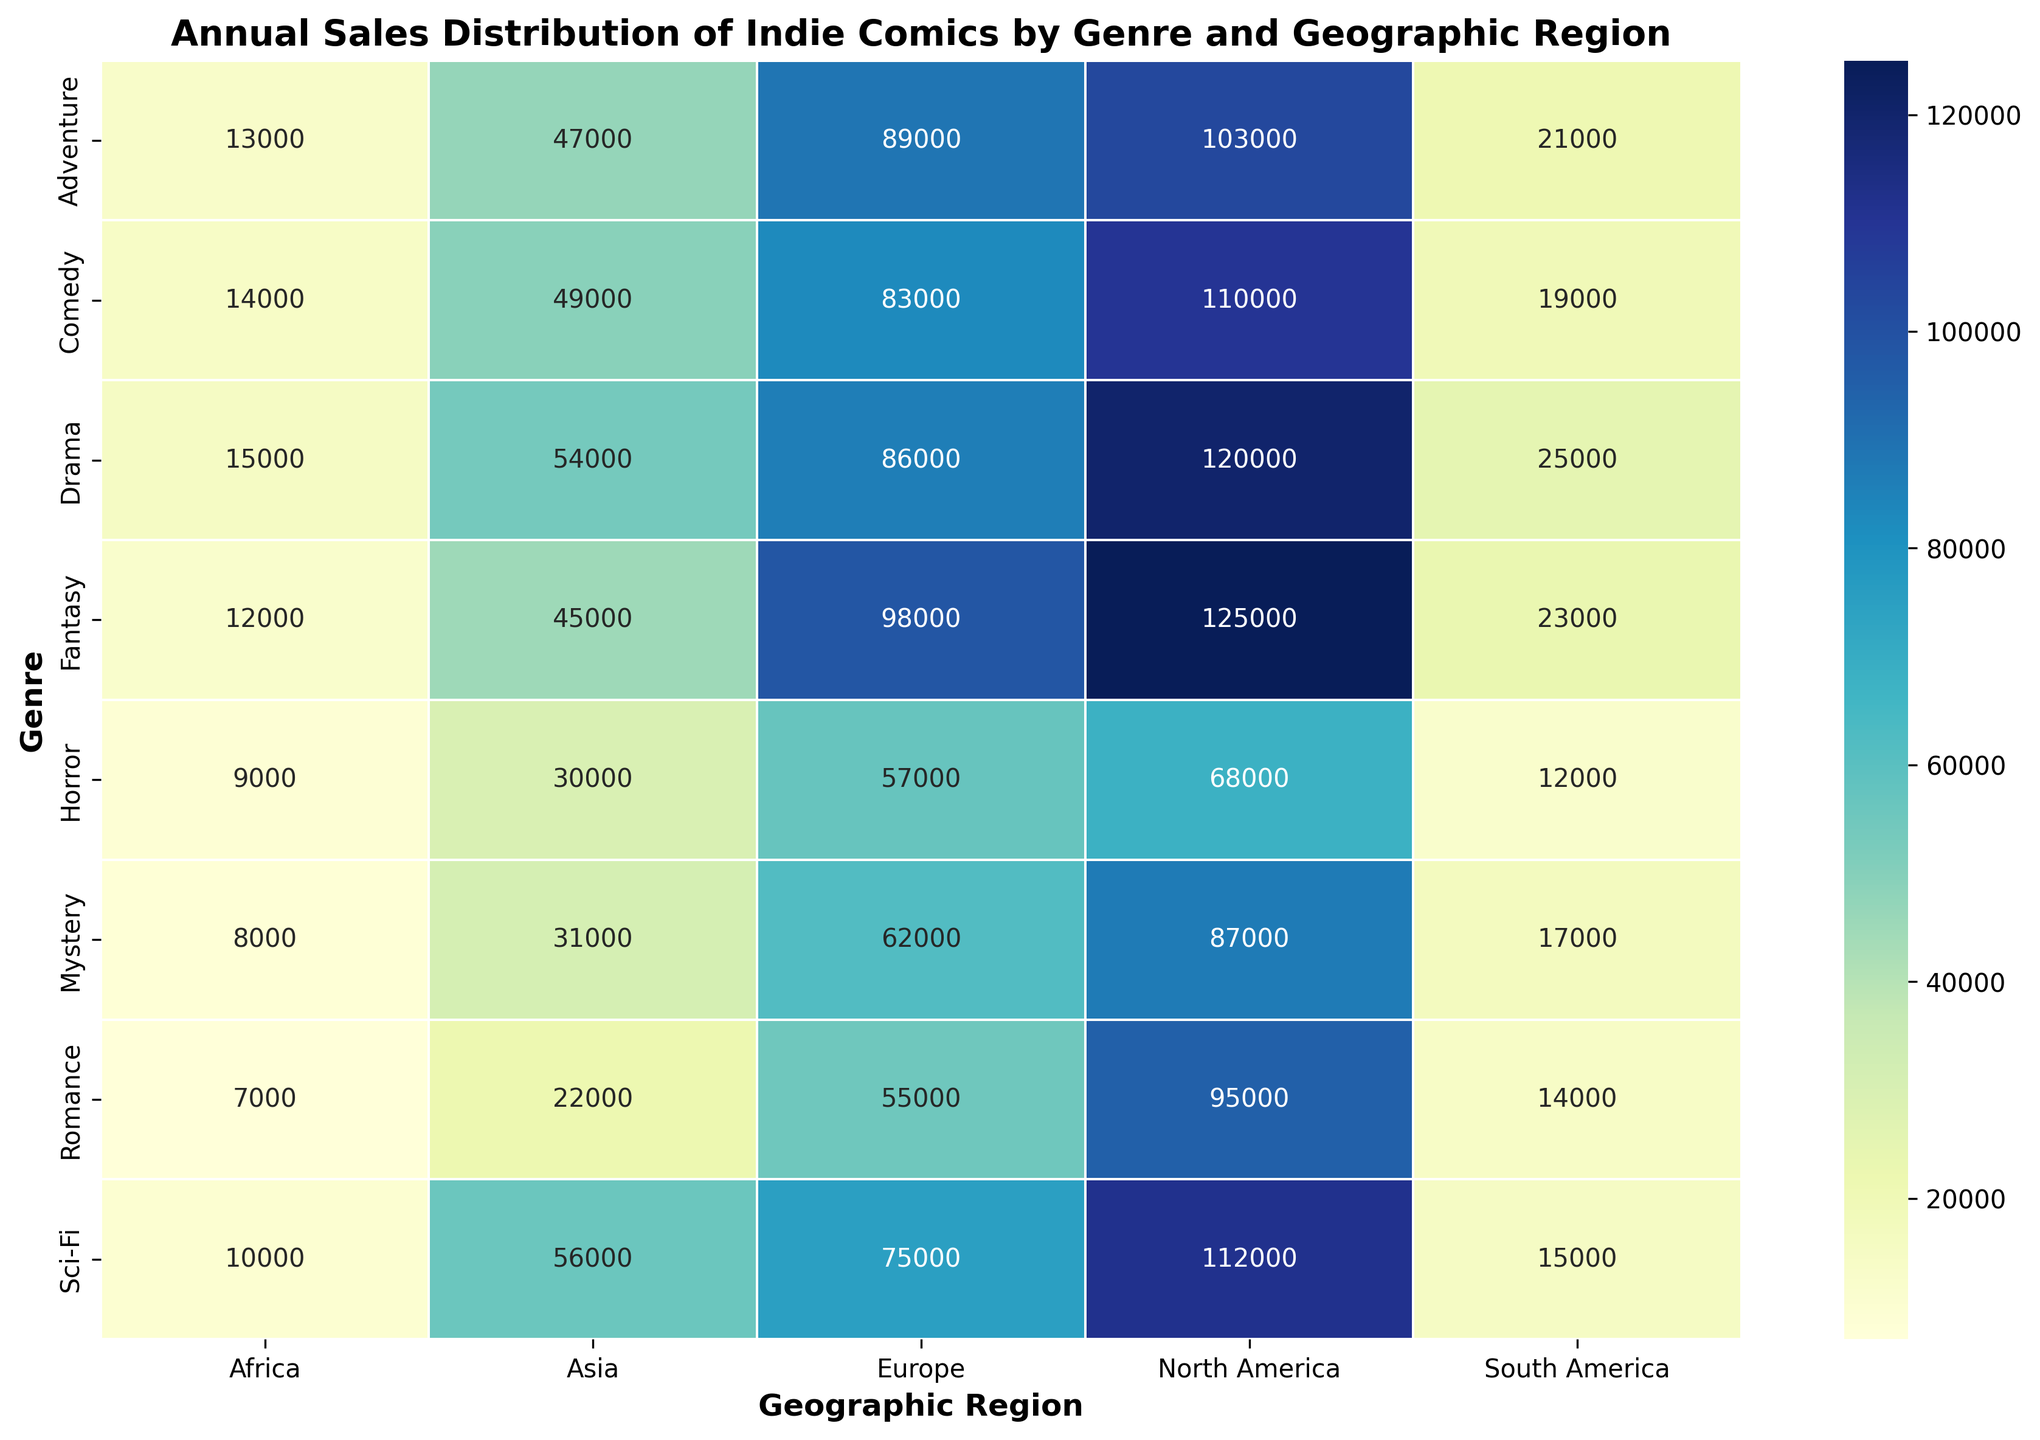What genre has the highest sales in North America? Look at the North America column and identify the highest value. The highest sales figure in North America is for Fantasy with 125,000.
Answer: Fantasy Which region has the lowest sales for Mystery comics? Look at the Mystery row and identify the smallest value in the row. The smallest sales figure for Mystery is in Africa with 8,000.
Answer: Africa How do sales of Sci-Fi comics in Europe compare to those in Asia? Look at the sales figures for Sci-Fi comics in both Europe and Asia. Europe has 75,000 sales and Asia has 56,000 sales. Compare these figures.
Answer: Higher in Europe What is the average sales volume for Romance comics across all regions? Sum the sales figures for Romance comics in all regions and then divide by the number of regions. \( (95000 + 55000 + 22000 + 14000 + 7000) / 5 = 193,000 / 5 \)
Answer: 38,600 Considering Adventure and Drama genres, which one has higher total sales in Europe and by how much? Add the sales of Adventure and Drama in Europe. Adventure: 89,000, Drama: 86,000. Subtract the two figures.
Answer: Adventure by 3,000 Which genre has the most visually intense color in North America, indicating highest sales, and what is the sales figure? Identify the genre with the darkest color in the North America column, which corresponds to the highest number.
Answer: Fantasy with 125,000 How do the sales of Comedy comics in Asia compare to the sales of Horror comics in North America? Compare the sales figures of Comedy in Asia (49,000) with those of Horror in North America (68,000).
Answer: Fewer in Asia Across all genres, what is the total sales volume in South America? Sum the sales figures for all genres in South America. \( 23000 + 15000 + 12000 + 14000 + 17000 + 21000 + 25000 + 19000 = 146,000 \)
Answer: 146,000 Which region shows the least variation in sales figures among all genres, and how can you tell from the heatmap? Look at the color intensity of each region's column and identify the one with the least variation in color shades.
Answer: Africa What is the total sales for the Comedy genre across all regions? Sum up the Comedy genre sales from North America, Europe, Asia, South America, and Africa. \( 110000 + 83000 + 49000 + 19000 + 14000 = 275,000 \)
Answer: 275,000 